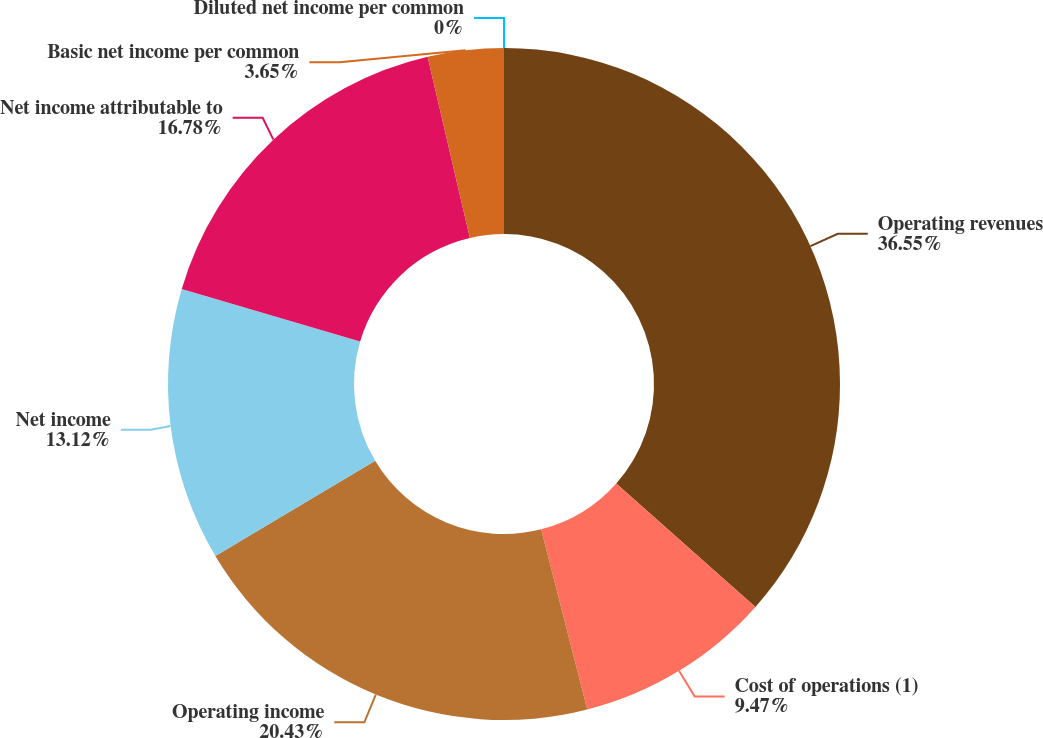Convert chart to OTSL. <chart><loc_0><loc_0><loc_500><loc_500><pie_chart><fcel>Operating revenues<fcel>Cost of operations (1)<fcel>Operating income<fcel>Net income<fcel>Net income attributable to<fcel>Basic net income per common<fcel>Diluted net income per common<nl><fcel>36.54%<fcel>9.47%<fcel>20.43%<fcel>13.12%<fcel>16.78%<fcel>3.65%<fcel>0.0%<nl></chart> 